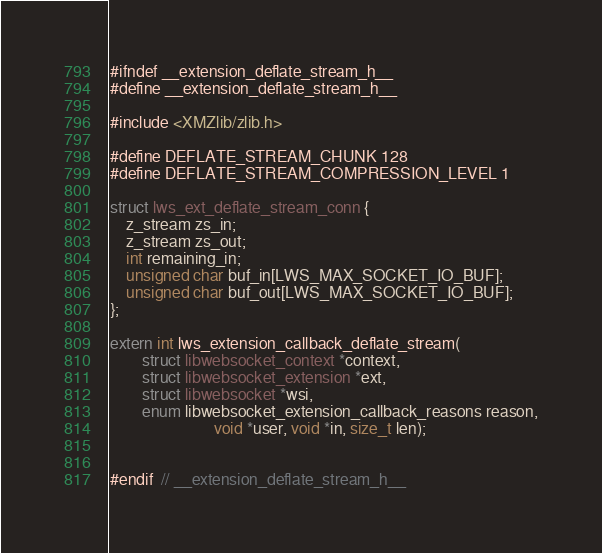<code> <loc_0><loc_0><loc_500><loc_500><_C_>#ifndef __extension_deflate_stream_h__
#define __extension_deflate_stream_h__

#include <XMZlib/zlib.h>

#define DEFLATE_STREAM_CHUNK 128
#define DEFLATE_STREAM_COMPRESSION_LEVEL 1

struct lws_ext_deflate_stream_conn {
	z_stream zs_in;
	z_stream zs_out;
	int remaining_in;
	unsigned char buf_in[LWS_MAX_SOCKET_IO_BUF];
	unsigned char buf_out[LWS_MAX_SOCKET_IO_BUF];
};

extern int lws_extension_callback_deflate_stream(
		struct libwebsocket_context *context,
		struct libwebsocket_extension *ext,
		struct libwebsocket *wsi,
		enum libwebsocket_extension_callback_reasons reason,
					      void *user, void *in, size_t len);


#endif  // __extension_deflate_stream_h__</code> 